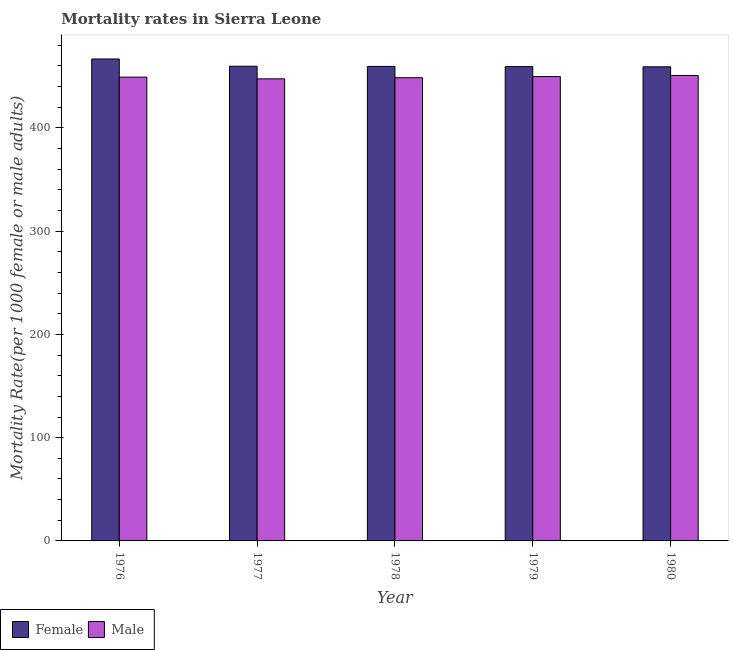How many different coloured bars are there?
Make the answer very short. 2. How many groups of bars are there?
Your answer should be very brief. 5. Are the number of bars per tick equal to the number of legend labels?
Provide a short and direct response. Yes. How many bars are there on the 3rd tick from the left?
Provide a short and direct response. 2. How many bars are there on the 4th tick from the right?
Offer a very short reply. 2. What is the female mortality rate in 1978?
Provide a short and direct response. 459.57. Across all years, what is the maximum female mortality rate?
Offer a terse response. 466.79. Across all years, what is the minimum female mortality rate?
Make the answer very short. 459.19. What is the total male mortality rate in the graph?
Your response must be concise. 2245.97. What is the difference between the female mortality rate in 1976 and that in 1980?
Make the answer very short. 7.6. What is the difference between the male mortality rate in 1977 and the female mortality rate in 1978?
Keep it short and to the point. -1.09. What is the average female mortality rate per year?
Your response must be concise. 460.94. In how many years, is the female mortality rate greater than 100?
Ensure brevity in your answer.  5. What is the ratio of the female mortality rate in 1977 to that in 1978?
Your answer should be very brief. 1. Is the female mortality rate in 1978 less than that in 1980?
Keep it short and to the point. No. Is the difference between the male mortality rate in 1976 and 1980 greater than the difference between the female mortality rate in 1976 and 1980?
Your answer should be compact. No. What is the difference between the highest and the second highest female mortality rate?
Offer a terse response. 7.03. What is the difference between the highest and the lowest female mortality rate?
Provide a short and direct response. 7.6. In how many years, is the male mortality rate greater than the average male mortality rate taken over all years?
Make the answer very short. 3. Is the sum of the female mortality rate in 1978 and 1979 greater than the maximum male mortality rate across all years?
Your answer should be compact. Yes. What does the 1st bar from the left in 1980 represents?
Your answer should be very brief. Female. Are all the bars in the graph horizontal?
Your answer should be very brief. No. How many years are there in the graph?
Offer a terse response. 5. What is the difference between two consecutive major ticks on the Y-axis?
Ensure brevity in your answer.  100. Are the values on the major ticks of Y-axis written in scientific E-notation?
Your response must be concise. No. How are the legend labels stacked?
Offer a terse response. Horizontal. What is the title of the graph?
Ensure brevity in your answer.  Mortality rates in Sierra Leone. What is the label or title of the Y-axis?
Provide a short and direct response. Mortality Rate(per 1000 female or male adults). What is the Mortality Rate(per 1000 female or male adults) of Female in 1976?
Your answer should be very brief. 466.79. What is the Mortality Rate(per 1000 female or male adults) in Male in 1976?
Make the answer very short. 449.21. What is the Mortality Rate(per 1000 female or male adults) in Female in 1977?
Your answer should be very brief. 459.76. What is the Mortality Rate(per 1000 female or male adults) in Male in 1977?
Make the answer very short. 447.56. What is the Mortality Rate(per 1000 female or male adults) of Female in 1978?
Provide a short and direct response. 459.57. What is the Mortality Rate(per 1000 female or male adults) in Male in 1978?
Your answer should be compact. 448.65. What is the Mortality Rate(per 1000 female or male adults) of Female in 1979?
Offer a very short reply. 459.38. What is the Mortality Rate(per 1000 female or male adults) in Male in 1979?
Make the answer very short. 449.73. What is the Mortality Rate(per 1000 female or male adults) in Female in 1980?
Your answer should be compact. 459.19. What is the Mortality Rate(per 1000 female or male adults) of Male in 1980?
Keep it short and to the point. 450.82. Across all years, what is the maximum Mortality Rate(per 1000 female or male adults) in Female?
Give a very brief answer. 466.79. Across all years, what is the maximum Mortality Rate(per 1000 female or male adults) of Male?
Keep it short and to the point. 450.82. Across all years, what is the minimum Mortality Rate(per 1000 female or male adults) in Female?
Offer a terse response. 459.19. Across all years, what is the minimum Mortality Rate(per 1000 female or male adults) of Male?
Give a very brief answer. 447.56. What is the total Mortality Rate(per 1000 female or male adults) of Female in the graph?
Provide a short and direct response. 2304.69. What is the total Mortality Rate(per 1000 female or male adults) in Male in the graph?
Your answer should be compact. 2245.97. What is the difference between the Mortality Rate(per 1000 female or male adults) in Female in 1976 and that in 1977?
Provide a succinct answer. 7.03. What is the difference between the Mortality Rate(per 1000 female or male adults) in Male in 1976 and that in 1977?
Your response must be concise. 1.65. What is the difference between the Mortality Rate(per 1000 female or male adults) of Female in 1976 and that in 1978?
Offer a very short reply. 7.22. What is the difference between the Mortality Rate(per 1000 female or male adults) in Male in 1976 and that in 1978?
Give a very brief answer. 0.56. What is the difference between the Mortality Rate(per 1000 female or male adults) of Female in 1976 and that in 1979?
Keep it short and to the point. 7.41. What is the difference between the Mortality Rate(per 1000 female or male adults) in Male in 1976 and that in 1979?
Make the answer very short. -0.53. What is the difference between the Mortality Rate(per 1000 female or male adults) in Female in 1976 and that in 1980?
Keep it short and to the point. 7.6. What is the difference between the Mortality Rate(per 1000 female or male adults) in Male in 1976 and that in 1980?
Give a very brief answer. -1.61. What is the difference between the Mortality Rate(per 1000 female or male adults) in Female in 1977 and that in 1978?
Give a very brief answer. 0.19. What is the difference between the Mortality Rate(per 1000 female or male adults) in Male in 1977 and that in 1978?
Offer a terse response. -1.09. What is the difference between the Mortality Rate(per 1000 female or male adults) in Female in 1977 and that in 1979?
Offer a terse response. 0.38. What is the difference between the Mortality Rate(per 1000 female or male adults) of Male in 1977 and that in 1979?
Offer a terse response. -2.18. What is the difference between the Mortality Rate(per 1000 female or male adults) of Female in 1977 and that in 1980?
Your response must be concise. 0.57. What is the difference between the Mortality Rate(per 1000 female or male adults) in Male in 1977 and that in 1980?
Make the answer very short. -3.27. What is the difference between the Mortality Rate(per 1000 female or male adults) in Female in 1978 and that in 1979?
Keep it short and to the point. 0.19. What is the difference between the Mortality Rate(per 1000 female or male adults) in Male in 1978 and that in 1979?
Ensure brevity in your answer.  -1.09. What is the difference between the Mortality Rate(per 1000 female or male adults) in Female in 1978 and that in 1980?
Keep it short and to the point. 0.38. What is the difference between the Mortality Rate(per 1000 female or male adults) of Male in 1978 and that in 1980?
Provide a short and direct response. -2.18. What is the difference between the Mortality Rate(per 1000 female or male adults) of Female in 1979 and that in 1980?
Make the answer very short. 0.19. What is the difference between the Mortality Rate(per 1000 female or male adults) in Male in 1979 and that in 1980?
Offer a very short reply. -1.09. What is the difference between the Mortality Rate(per 1000 female or male adults) in Female in 1976 and the Mortality Rate(per 1000 female or male adults) in Male in 1977?
Keep it short and to the point. 19.24. What is the difference between the Mortality Rate(per 1000 female or male adults) of Female in 1976 and the Mortality Rate(per 1000 female or male adults) of Male in 1978?
Offer a very short reply. 18.15. What is the difference between the Mortality Rate(per 1000 female or male adults) in Female in 1976 and the Mortality Rate(per 1000 female or male adults) in Male in 1979?
Give a very brief answer. 17.06. What is the difference between the Mortality Rate(per 1000 female or male adults) of Female in 1976 and the Mortality Rate(per 1000 female or male adults) of Male in 1980?
Provide a succinct answer. 15.97. What is the difference between the Mortality Rate(per 1000 female or male adults) of Female in 1977 and the Mortality Rate(per 1000 female or male adults) of Male in 1978?
Provide a succinct answer. 11.11. What is the difference between the Mortality Rate(per 1000 female or male adults) in Female in 1977 and the Mortality Rate(per 1000 female or male adults) in Male in 1979?
Keep it short and to the point. 10.03. What is the difference between the Mortality Rate(per 1000 female or male adults) of Female in 1977 and the Mortality Rate(per 1000 female or male adults) of Male in 1980?
Keep it short and to the point. 8.94. What is the difference between the Mortality Rate(per 1000 female or male adults) in Female in 1978 and the Mortality Rate(per 1000 female or male adults) in Male in 1979?
Give a very brief answer. 9.84. What is the difference between the Mortality Rate(per 1000 female or male adults) in Female in 1978 and the Mortality Rate(per 1000 female or male adults) in Male in 1980?
Your response must be concise. 8.75. What is the difference between the Mortality Rate(per 1000 female or male adults) of Female in 1979 and the Mortality Rate(per 1000 female or male adults) of Male in 1980?
Keep it short and to the point. 8.56. What is the average Mortality Rate(per 1000 female or male adults) in Female per year?
Provide a succinct answer. 460.94. What is the average Mortality Rate(per 1000 female or male adults) in Male per year?
Ensure brevity in your answer.  449.19. In the year 1976, what is the difference between the Mortality Rate(per 1000 female or male adults) in Female and Mortality Rate(per 1000 female or male adults) in Male?
Your answer should be very brief. 17.59. In the year 1977, what is the difference between the Mortality Rate(per 1000 female or male adults) of Female and Mortality Rate(per 1000 female or male adults) of Male?
Make the answer very short. 12.2. In the year 1978, what is the difference between the Mortality Rate(per 1000 female or male adults) of Female and Mortality Rate(per 1000 female or male adults) of Male?
Give a very brief answer. 10.92. In the year 1979, what is the difference between the Mortality Rate(per 1000 female or male adults) in Female and Mortality Rate(per 1000 female or male adults) in Male?
Your answer should be compact. 9.65. In the year 1980, what is the difference between the Mortality Rate(per 1000 female or male adults) in Female and Mortality Rate(per 1000 female or male adults) in Male?
Offer a very short reply. 8.37. What is the ratio of the Mortality Rate(per 1000 female or male adults) in Female in 1976 to that in 1977?
Provide a succinct answer. 1.02. What is the ratio of the Mortality Rate(per 1000 female or male adults) in Female in 1976 to that in 1978?
Make the answer very short. 1.02. What is the ratio of the Mortality Rate(per 1000 female or male adults) of Male in 1976 to that in 1978?
Offer a very short reply. 1. What is the ratio of the Mortality Rate(per 1000 female or male adults) of Female in 1976 to that in 1979?
Your answer should be very brief. 1.02. What is the ratio of the Mortality Rate(per 1000 female or male adults) of Male in 1976 to that in 1979?
Keep it short and to the point. 1. What is the ratio of the Mortality Rate(per 1000 female or male adults) in Female in 1976 to that in 1980?
Ensure brevity in your answer.  1.02. What is the ratio of the Mortality Rate(per 1000 female or male adults) of Male in 1976 to that in 1980?
Your answer should be compact. 1. What is the ratio of the Mortality Rate(per 1000 female or male adults) in Female in 1977 to that in 1978?
Your response must be concise. 1. What is the ratio of the Mortality Rate(per 1000 female or male adults) of Female in 1977 to that in 1979?
Make the answer very short. 1. What is the ratio of the Mortality Rate(per 1000 female or male adults) in Male in 1977 to that in 1980?
Provide a succinct answer. 0.99. What is the ratio of the Mortality Rate(per 1000 female or male adults) in Female in 1978 to that in 1979?
Ensure brevity in your answer.  1. What is the ratio of the Mortality Rate(per 1000 female or male adults) in Male in 1978 to that in 1980?
Keep it short and to the point. 1. What is the ratio of the Mortality Rate(per 1000 female or male adults) of Female in 1979 to that in 1980?
Your response must be concise. 1. What is the difference between the highest and the second highest Mortality Rate(per 1000 female or male adults) of Female?
Give a very brief answer. 7.03. What is the difference between the highest and the second highest Mortality Rate(per 1000 female or male adults) in Male?
Provide a short and direct response. 1.09. What is the difference between the highest and the lowest Mortality Rate(per 1000 female or male adults) in Female?
Your answer should be very brief. 7.6. What is the difference between the highest and the lowest Mortality Rate(per 1000 female or male adults) in Male?
Offer a very short reply. 3.27. 